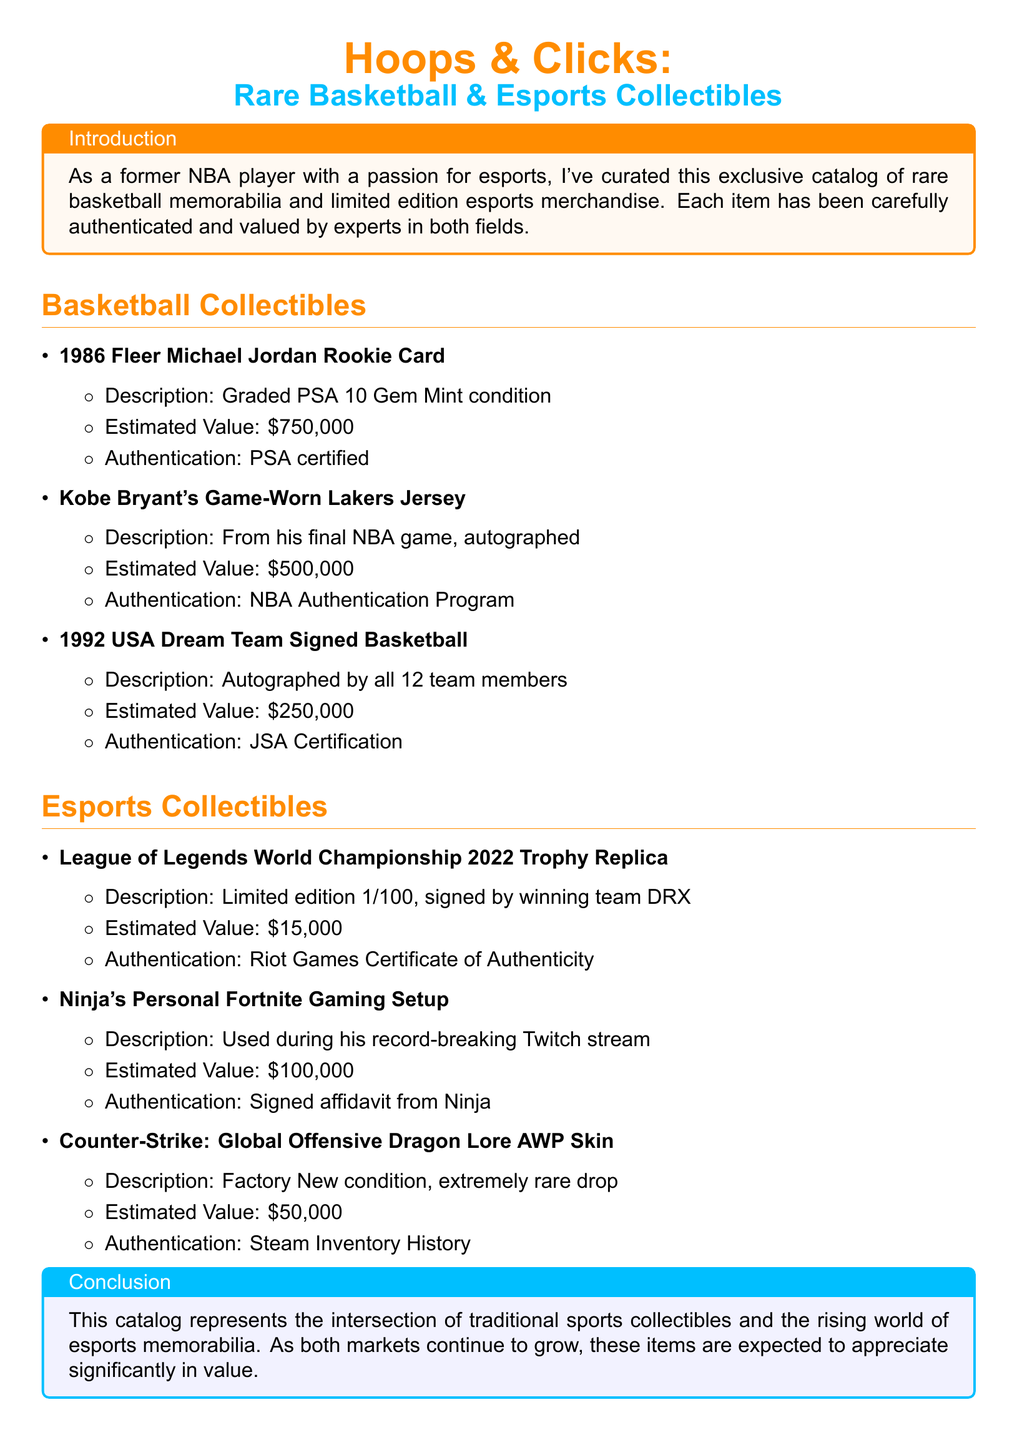What is the estimated value of the 1986 Fleer Michael Jordan Rookie Card? The estimated value is located in the section about basketball collectibles. It states that the 1986 Fleer Michael Jordan Rookie Card is valued at $750,000.
Answer: $750,000 Who authenticated Kobe Bryant's game-worn Lakers jersey? The authentication details are provided for each collectible, indicating that the authentication for Kobe Bryant's jersey is through the NBA Authentication Program.
Answer: NBA Authentication Program What is the description of the League of Legends World Championship 2022 Trophy Replica? The description is summarized in the document, explaining that it is a limited edition item, specifically 1 out of 100, and signed by the winning team DRX.
Answer: Limited edition 1/100, signed by winning team DRX How many team members signed the 1992 USA Dream Team Signed Basketball? The information is summarized in the document, indicating that all 12 team members autographed the basketball.
Answer: 12 What is the estimated value of Ninja's personal Fortnite gaming setup? The estimated value is provided in the esports collectibles section, which states that it is valued at $100,000.
Answer: $100,000 What type of authentication is required for the Counter-Strike: Global Offensive Dragon Lore AWP Skin? The document specifies that the authentication for this esports collectible can be confirmed through Steam Inventory History.
Answer: Steam Inventory History Which item is described as being from Kobe Bryant's final NBA game? In the basketball collectibles section, the description of the game-worn Lakers jersey indicates that it is from his final NBA game.
Answer: Game-Worn Lakers Jersey What is the conclusion of the catalog regarding the markets of collectibles? The conclusion summarizes the growth potential of both traditional sports collectibles and esports memorabilia, noting that the items are expected to appreciate significantly in value.
Answer: Appreciate significantly in value 